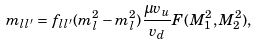<formula> <loc_0><loc_0><loc_500><loc_500>m _ { l l ^ { \prime } } = f _ { l l ^ { \prime } } ( m _ { l } ^ { 2 } - m _ { l } ^ { 2 } ) \frac { \mu v _ { u } } { v _ { d } } F ( M _ { 1 } ^ { 2 } , M _ { 2 } ^ { 2 } ) ,</formula> 